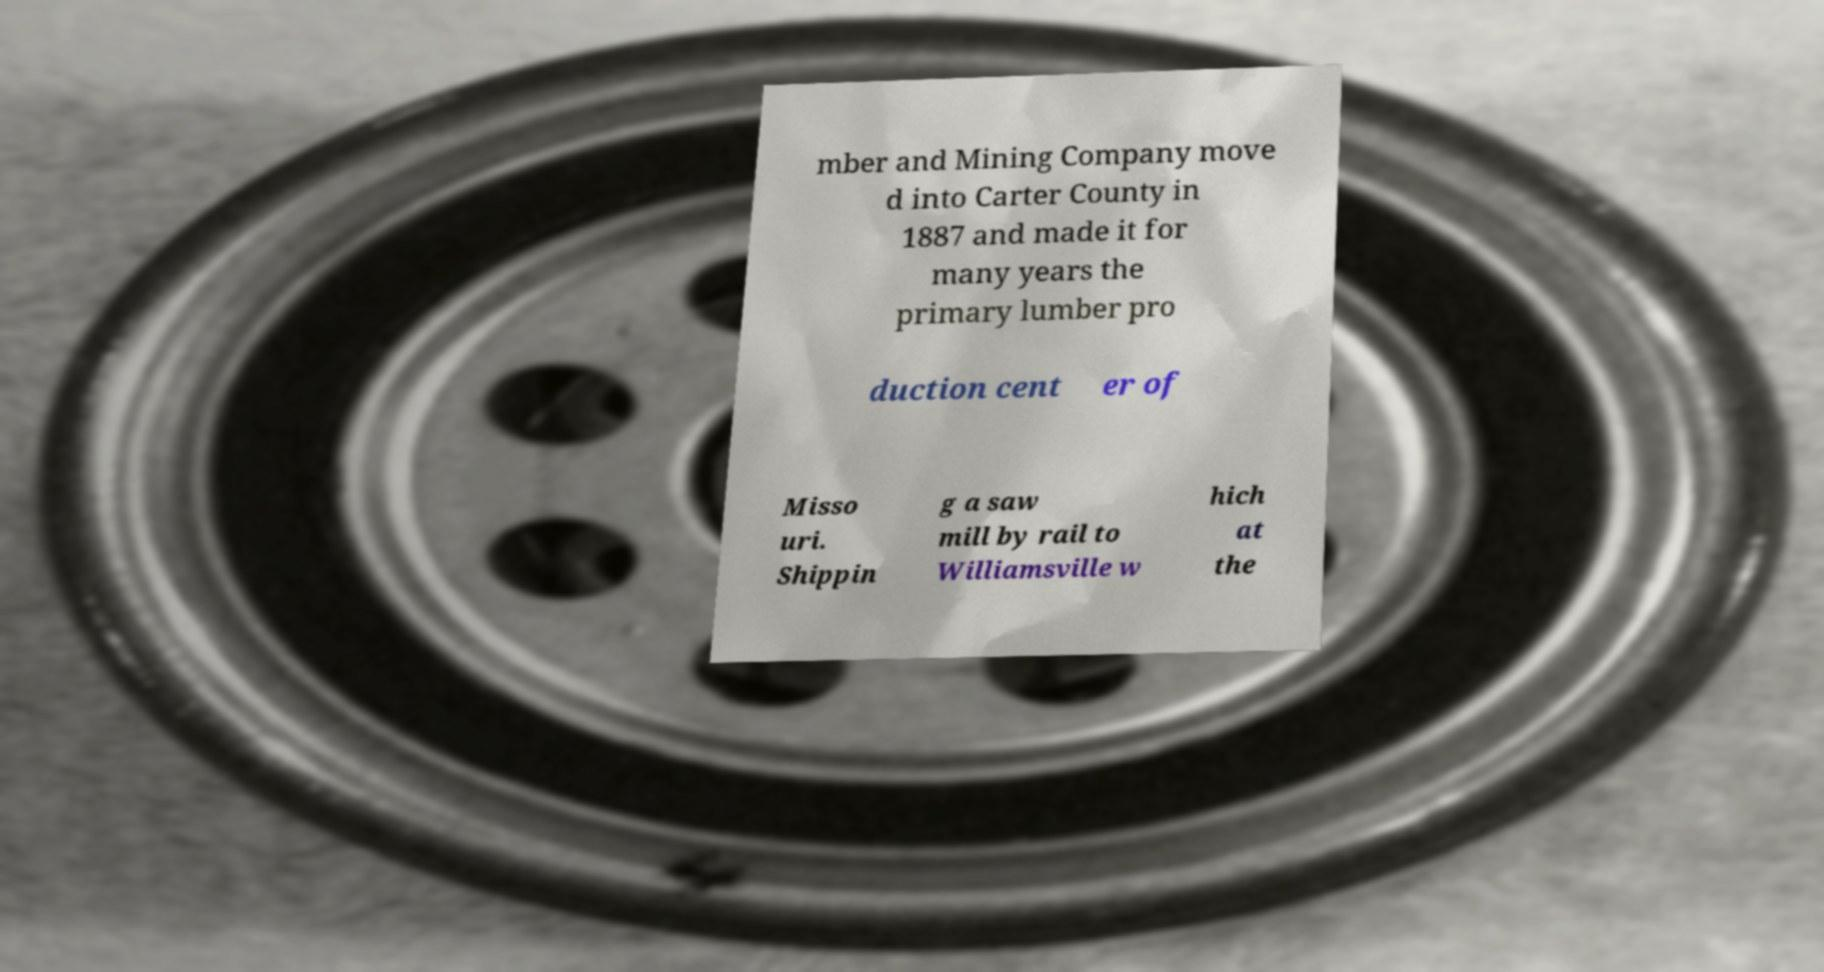Can you accurately transcribe the text from the provided image for me? mber and Mining Company move d into Carter County in 1887 and made it for many years the primary lumber pro duction cent er of Misso uri. Shippin g a saw mill by rail to Williamsville w hich at the 